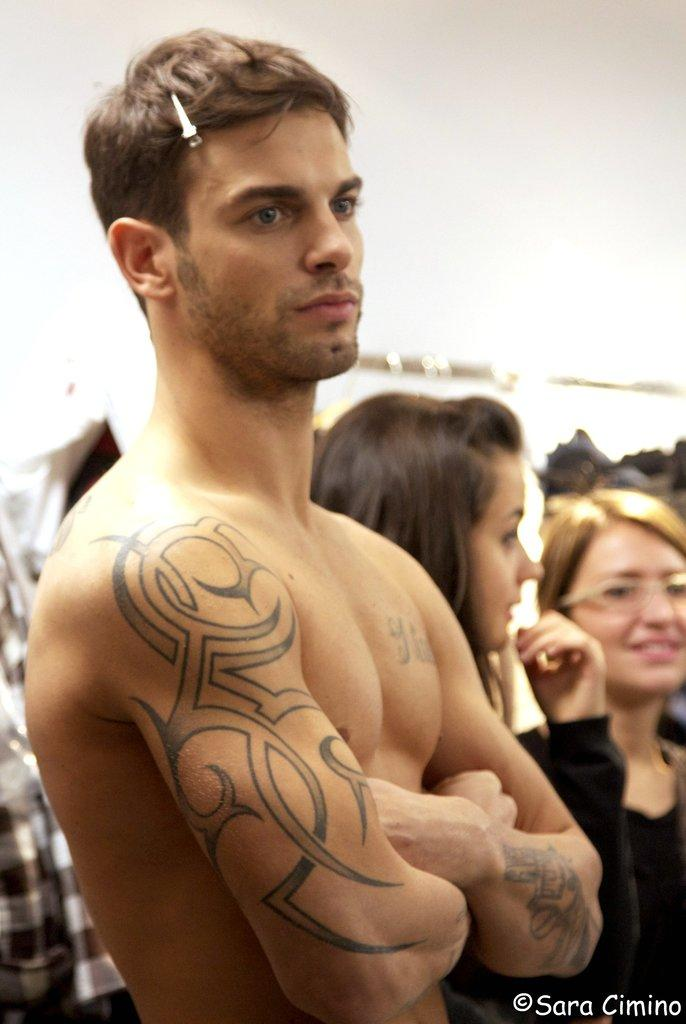What is happening in the image? There are people standing in the image. Can you describe the clothing of the people? The people are wearing different color dresses. What can be seen in the background of the image? The background of the image is white. Are there any fish swimming in the territory of the tiger in the image? There are no fish or tigers present in the image; it features people standing in different color dresses with a white background. 